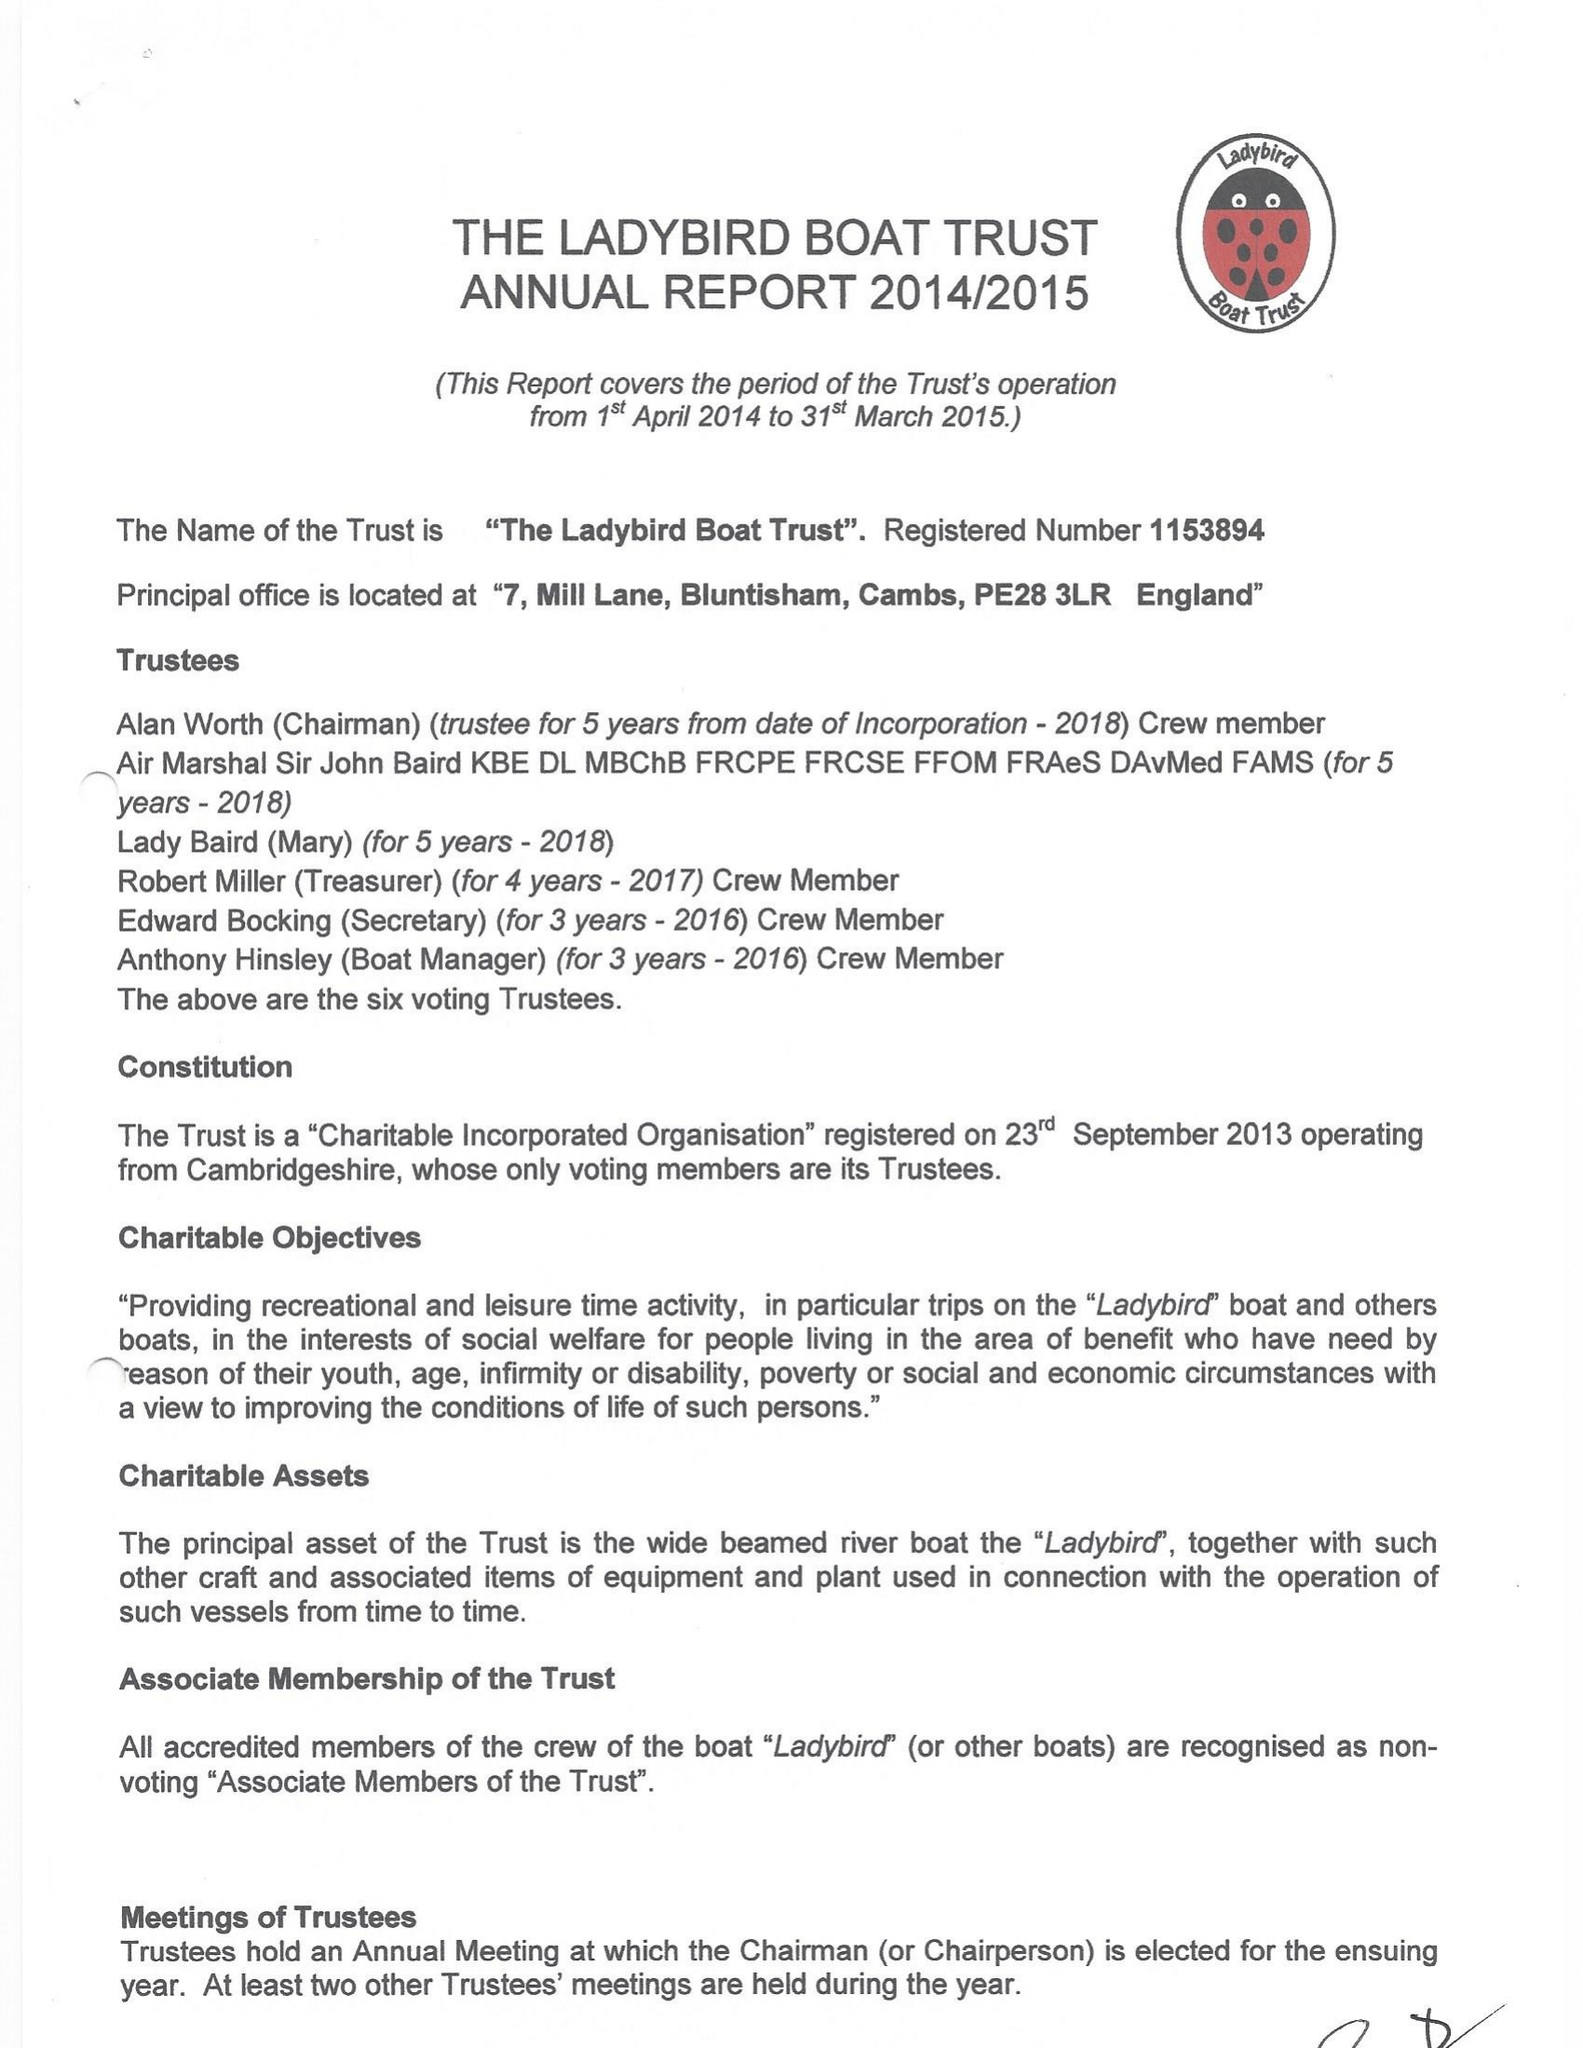What is the value for the report_date?
Answer the question using a single word or phrase. 2015-03-31 